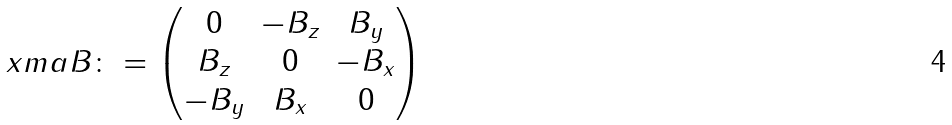Convert formula to latex. <formula><loc_0><loc_0><loc_500><loc_500>\ x m a { B } \colon = \begin{pmatrix} 0 & - B _ { z } & B _ { y } \\ B _ { z } & 0 & - B _ { x } \\ - B _ { y } & B _ { x } & 0 \end{pmatrix}</formula> 